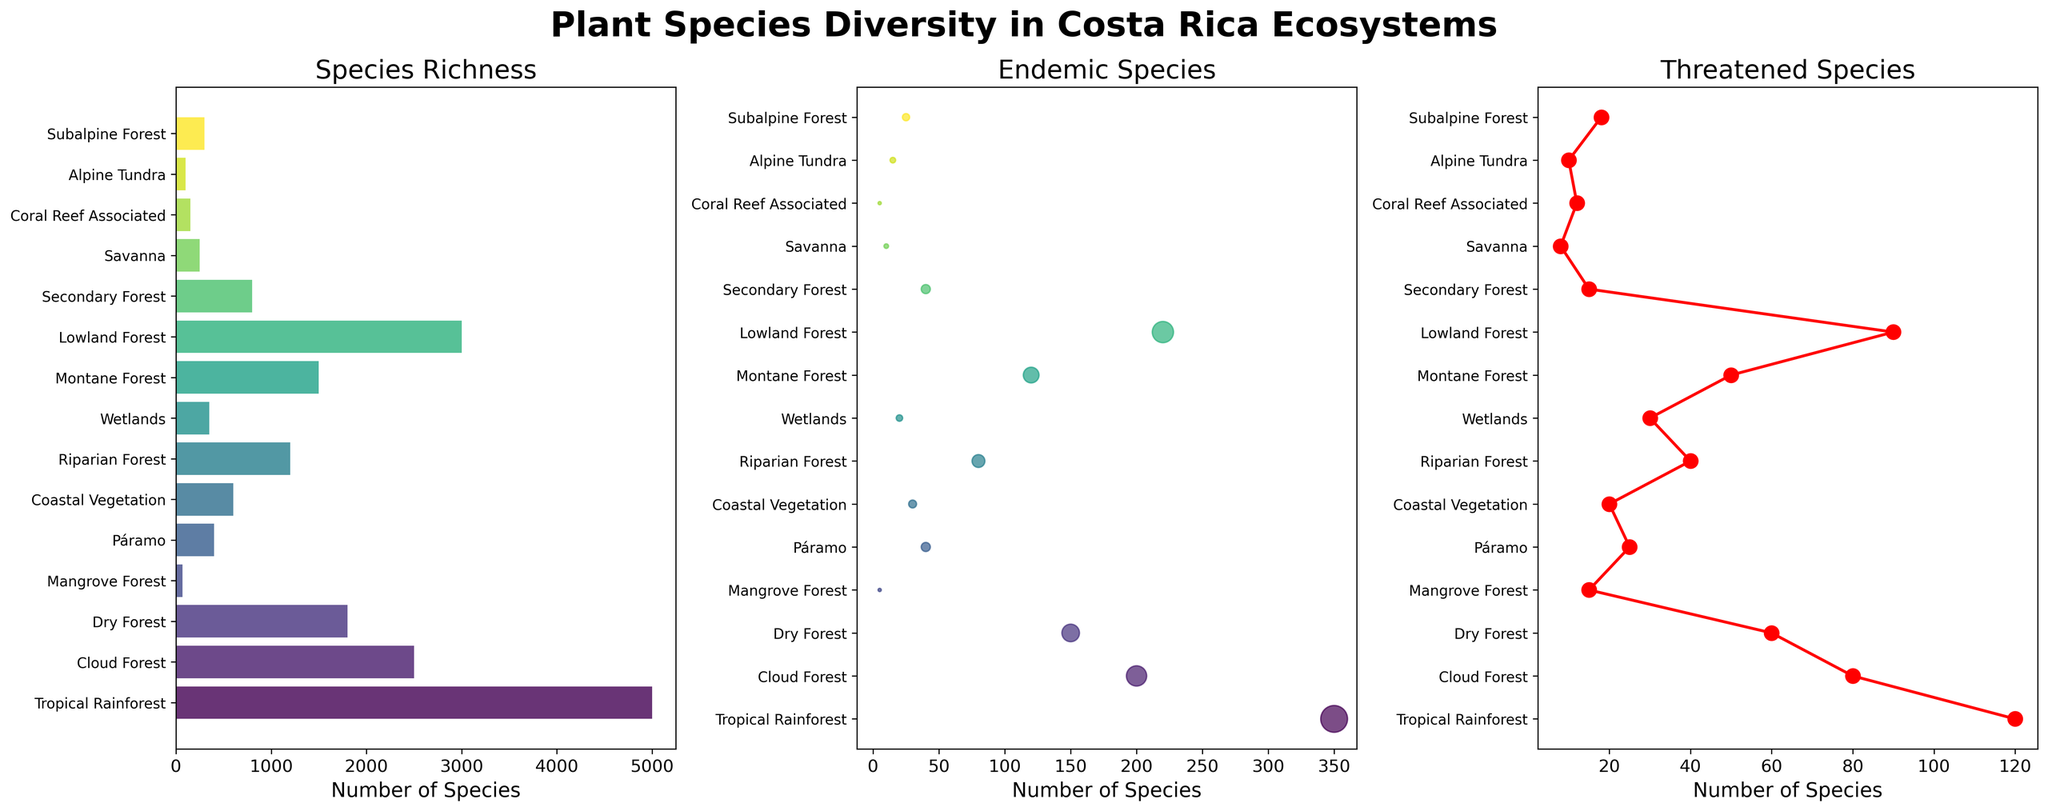Which ecosystem has the highest species richness? The first subplot shows species richness. By observing the length of the bars, the longest bar corresponds to the Tropical Rainforest, indicating the highest species richness.
Answer: Tropical Rainforest In which ecosystem are the number of endemic species and threatened species both higher than 100? By examining the scatter plot in the second subplot and the line plot in the third subplot, we find that the Lowland Forest has 220 endemic species and 90 threatened species, which satisfies the condition.
Answer: Lowland Forest What is the combined total count of endemic species in the Dry Forest and the Cloud Forest? From the second subplot, the Dry Forest has 150 and the Cloud Forest has 200 endemic species. Adding these together gives 150 + 200 = 350.
Answer: 350 Which ecosystem has the least number of endemic species, and how many are there? In the second subplot, the smallest scatter point represents Mangrove Forest, which has 5 endemic species.
Answer: Mangrove Forest, 5 What is the average number of threatened species across all ecosystems? Sum the number of threatened species for all ecosystems, then divide by the number of ecosystems: (120 + 80 + 60 + 15 + 25 + 20 + 40 + 30 + 50 + 90 + 15 + 8 + 12 + 10 + 18) / 15 = 593 / 15 ≈ 39.53.
Answer: 39.53 Which ecosystem has a total species richness closest to 1000, and how close is it? From the first subplot, Secondary Forest with a species richness of 800 is closest to 1000, and the difference is 1000 - 800 = 200.
Answer: Secondary Forest, 200 What is the difference in the number of threatened species between the Montane Forest and the Páramo? In the third subplot, Montane Forest has 50 threatened species and Páramo has 25. The difference is 50 - 25 = 25.
Answer: 25 How does the number of endemic species in the Coastal Vegetation compare with the Subalpine Forest? From the second subplot, Coastal Vegetation has 30 endemic species and Subalpine Forest has 25. Coastal Vegetation has 5 more endemic species than Subalpine Forest.
Answer: Coastal Vegetation has 5 more Which ecosystem has the smallest number of threatened species, and what is the number? In the third subplot, the Savanna has the smallest red dot with 8 threatened species.
Answer: Savanna, 8 What proportion of ecosystems have species richness greater than 1500? Count the number of ecosystems with species richness over 1500 from the first subplot: Tropical Rainforest, Cloud Forest, Lowland Forest, Montane Forest, Dry Forest (5 out of 15 ecosystems). The proportion is 5 / 15 = 0.33.
Answer: 0.33 